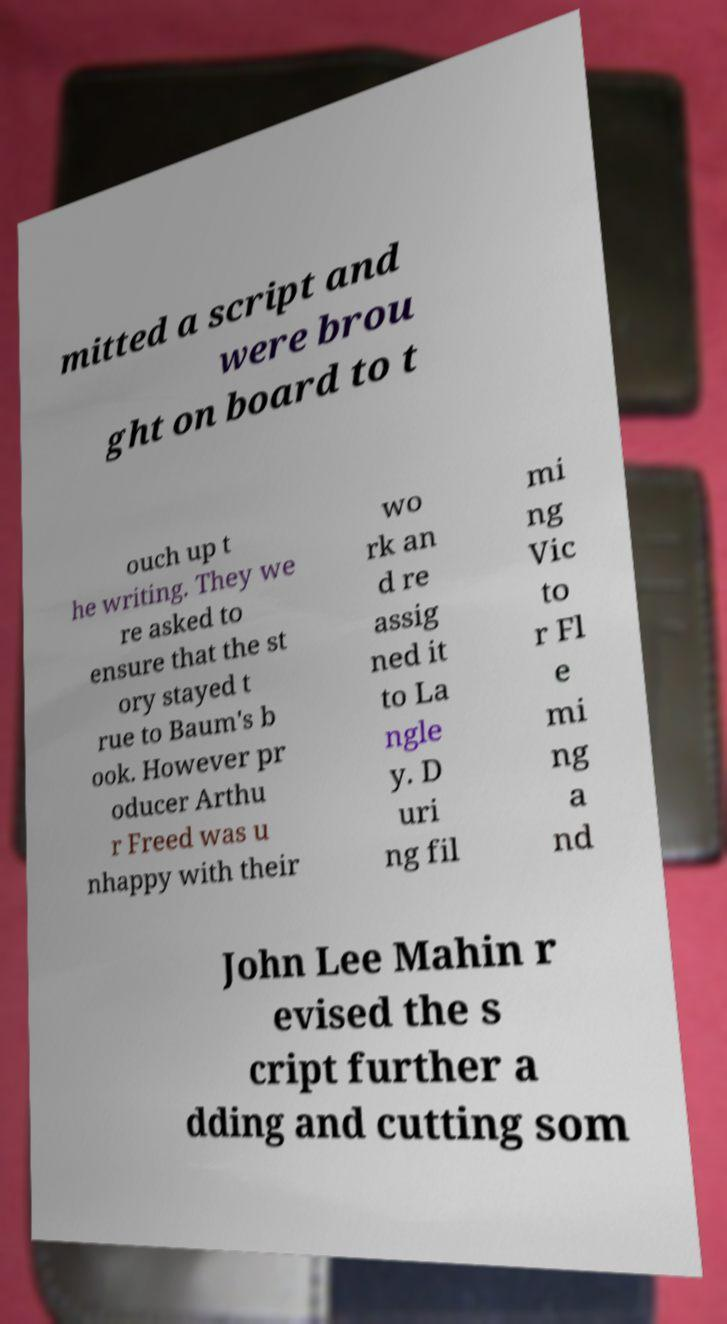For documentation purposes, I need the text within this image transcribed. Could you provide that? mitted a script and were brou ght on board to t ouch up t he writing. They we re asked to ensure that the st ory stayed t rue to Baum's b ook. However pr oducer Arthu r Freed was u nhappy with their wo rk an d re assig ned it to La ngle y. D uri ng fil mi ng Vic to r Fl e mi ng a nd John Lee Mahin r evised the s cript further a dding and cutting som 